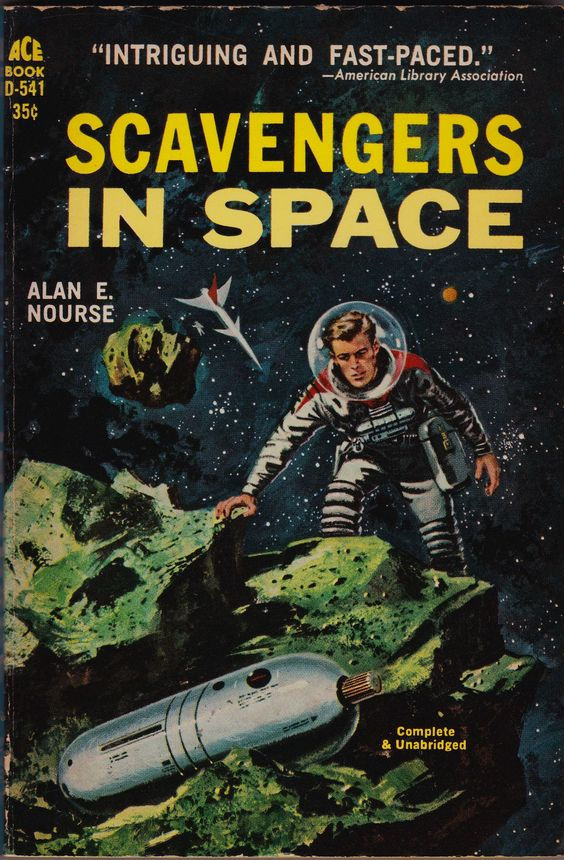describe this image as a stable diffusion prompt Retro science fiction book cover, space adventure, astronaut in a spacesuit exploring an alien planet, floating green rocks, spaceship in the background, vintage style, dramatic lighting, 1950s sci-fi illustration. 